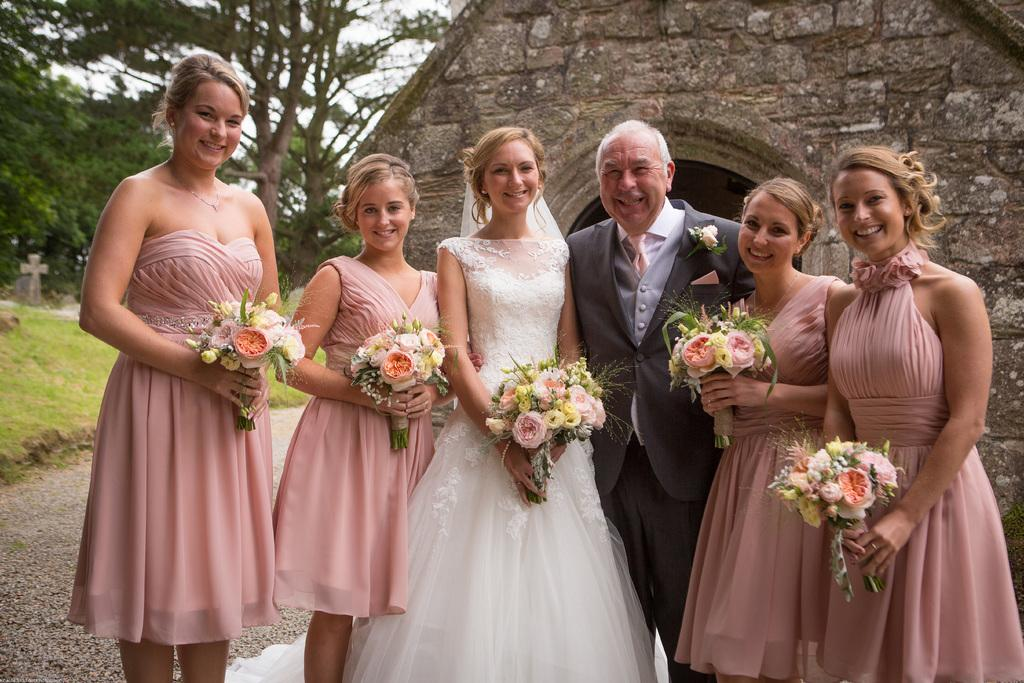How many people are in the image? There are people in the image, but the exact number is not specified. What are some of the people holding in the image? Some of the people are holding flower bouquets in the image. What type of vegetation is present in the image? There are trees in the image. What religious symbol can be seen in the image? There is a cross symbol in the image. What type of structure is visible in the image? There is a house in the image. What is visible in the sky in the image? The sky is visible in the image. How many dimes are scattered on the ground in the image? There is no mention of dimes in the image, so we cannot determine their presence or quantity. 